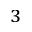<formula> <loc_0><loc_0><loc_500><loc_500>_ { 3 }</formula> 